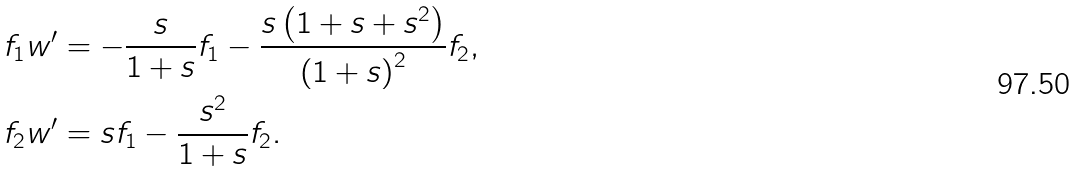<formula> <loc_0><loc_0><loc_500><loc_500>f _ { 1 } w ^ { \prime } & = - \frac { s } { 1 + s } f _ { 1 } - \frac { s \left ( 1 + s + s ^ { 2 } \right ) } { \left ( 1 + s \right ) ^ { 2 } } f _ { 2 } , \\ f _ { 2 } w ^ { \prime } & = s f _ { 1 } - \frac { s ^ { 2 } } { 1 + s } f _ { 2 } .</formula> 